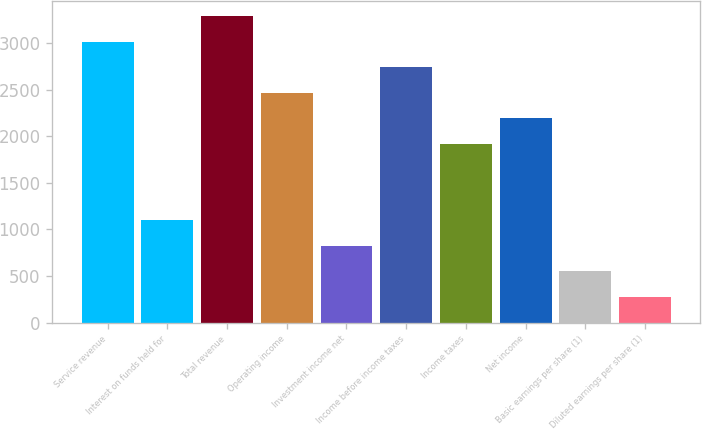Convert chart. <chart><loc_0><loc_0><loc_500><loc_500><bar_chart><fcel>Service revenue<fcel>Interest on funds held for<fcel>Total revenue<fcel>Operating income<fcel>Investment income net<fcel>Income before income taxes<fcel>Income taxes<fcel>Net income<fcel>Basic earnings per share (1)<fcel>Diluted earnings per share (1)<nl><fcel>3013.43<fcel>1096.76<fcel>3287.24<fcel>2465.81<fcel>822.95<fcel>2739.62<fcel>1918.19<fcel>2192<fcel>549.14<fcel>275.33<nl></chart> 